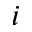<formula> <loc_0><loc_0><loc_500><loc_500>i</formula> 